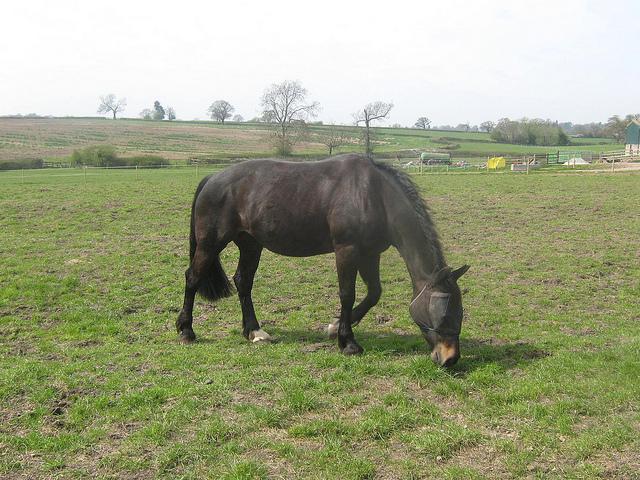Is that an ass?
Be succinct. No. Is this grass lush?
Be succinct. No. What kind of animals are shown?
Short answer required. Horse. Is the animal eating?
Give a very brief answer. Yes. 